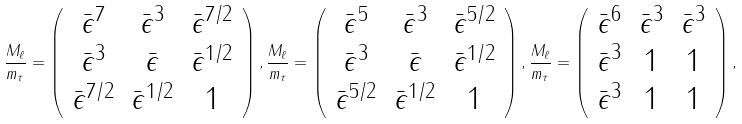Convert formula to latex. <formula><loc_0><loc_0><loc_500><loc_500>\frac { M _ { \ell } } { m _ { \tau } } = \left ( \begin{array} { c c c } \bar { \epsilon } ^ { 7 } & \bar { \epsilon } ^ { 3 } & \bar { \epsilon } ^ { 7 / 2 } \\ \bar { \epsilon } ^ { 3 } & \bar { \epsilon } & \bar { \epsilon } ^ { 1 / 2 } \\ \bar { \epsilon } ^ { 7 / 2 } & \bar { \epsilon } ^ { 1 / 2 } & 1 \end{array} \right ) , \frac { M _ { \ell } } { m _ { \tau } } = \left ( \begin{array} { c c c } \bar { \epsilon } ^ { 5 } & \bar { \epsilon } ^ { 3 } & \bar { \epsilon } ^ { 5 / 2 } \\ \bar { \epsilon } ^ { 3 } & \bar { \epsilon } & \bar { \epsilon } ^ { 1 / 2 } \\ \bar { \epsilon } ^ { 5 / 2 } & \bar { \epsilon } ^ { 1 / 2 } & 1 \end{array} \right ) , \frac { M _ { \ell } } { m _ { \tau } } = \left ( \begin{array} { c c c } \bar { \epsilon } ^ { 6 } & \bar { \epsilon } ^ { 3 } & \bar { \epsilon } ^ { 3 } \\ \bar { \epsilon } ^ { 3 } & 1 & 1 \\ \bar { \epsilon } ^ { 3 } & 1 & 1 \end{array} \right ) ,</formula> 